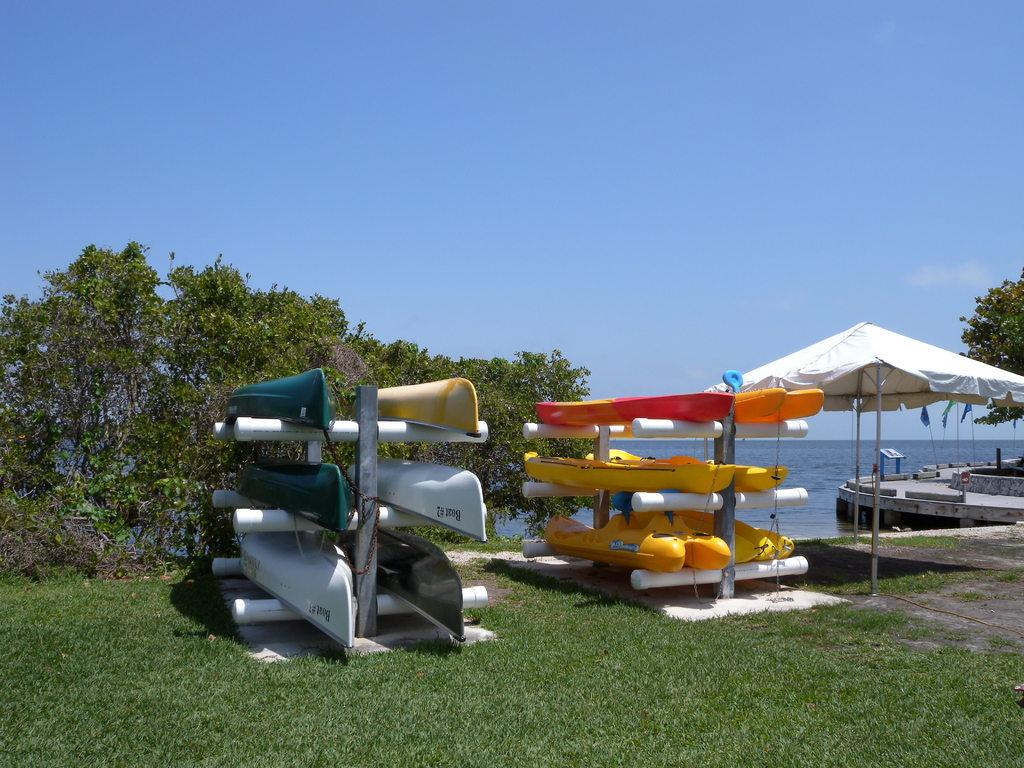What type of boats can be seen in the image? There are kayak boats arranged in the stands. What type of shade is provided in the image? Parasols are present in the image. What type of structure is visible in the image? There is a walkway bridge in the image. What is attached to flag posts in the image? Flags are attached to flag posts. What type of vegetation is visible in the image? Trees are visible in the image. What type of natural feature is present in the image? Water is present in the image. What part of the natural environment is visible in the image? The sky is visible in the image. What type of produce is being sold at the market in the image? There is no market or produce present in the image. What type of bag is being used by the person in the image? There is no person or bag present in the image. 